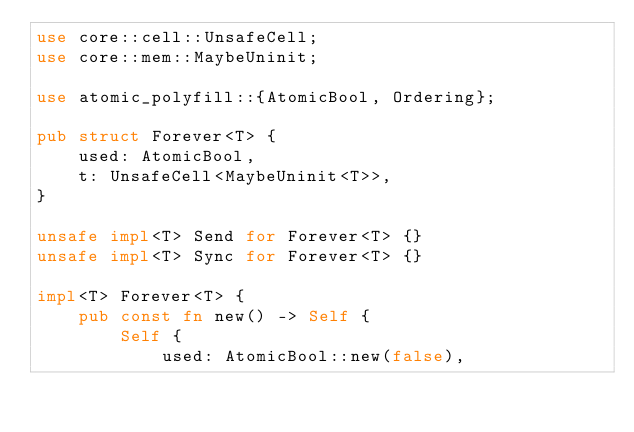Convert code to text. <code><loc_0><loc_0><loc_500><loc_500><_Rust_>use core::cell::UnsafeCell;
use core::mem::MaybeUninit;

use atomic_polyfill::{AtomicBool, Ordering};

pub struct Forever<T> {
    used: AtomicBool,
    t: UnsafeCell<MaybeUninit<T>>,
}

unsafe impl<T> Send for Forever<T> {}
unsafe impl<T> Sync for Forever<T> {}

impl<T> Forever<T> {
    pub const fn new() -> Self {
        Self {
            used: AtomicBool::new(false),</code> 